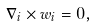Convert formula to latex. <formula><loc_0><loc_0><loc_500><loc_500>\nabla _ { i } \times { w } _ { i } = { 0 } ,</formula> 